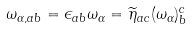<formula> <loc_0><loc_0><loc_500><loc_500>\omega _ { \alpha , a b } = \epsilon _ { a b } \omega _ { \alpha } = \widetilde { \eta } _ { a c } ( \omega _ { \alpha } ) ^ { c } _ { b }</formula> 